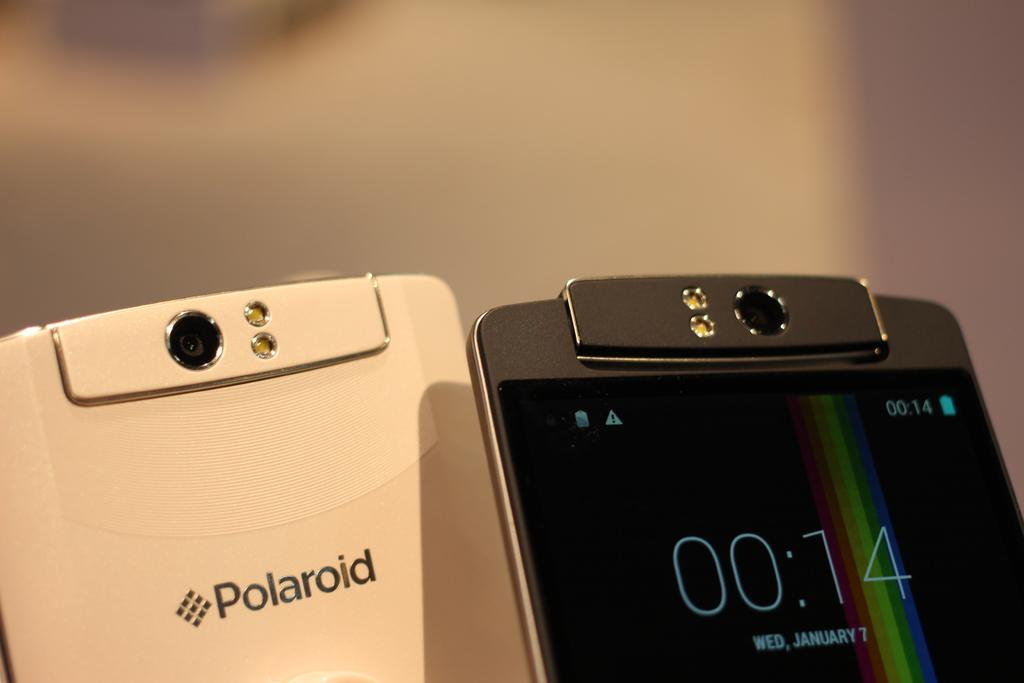Provide a one-sentence caption for the provided image. Two Polaroid phones displayed next to each other. 